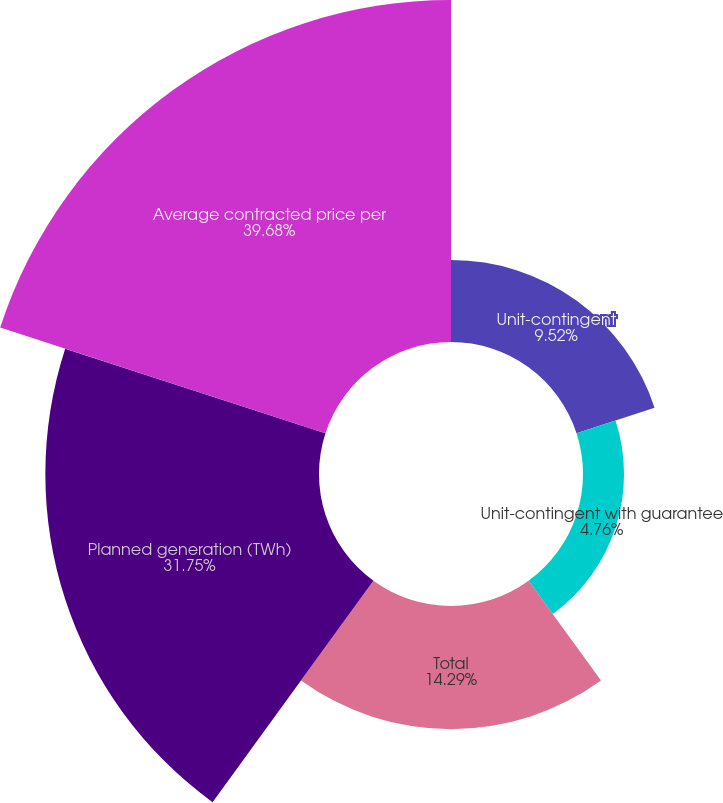Convert chart to OTSL. <chart><loc_0><loc_0><loc_500><loc_500><pie_chart><fcel>Unit-contingent<fcel>Unit-contingent with guarantee<fcel>Total<fcel>Planned generation (TWh)<fcel>Average contracted price per<nl><fcel>9.52%<fcel>4.76%<fcel>14.29%<fcel>31.75%<fcel>39.68%<nl></chart> 